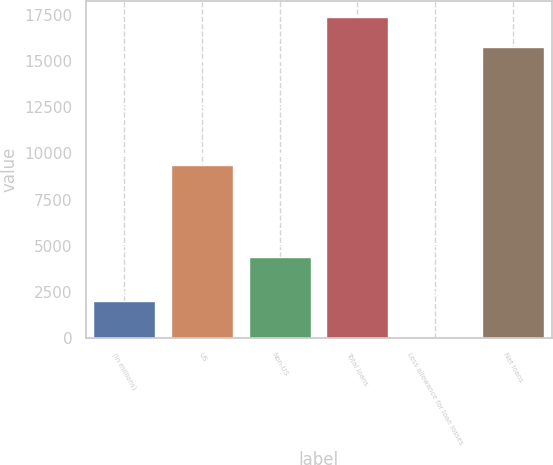<chart> <loc_0><loc_0><loc_500><loc_500><bar_chart><fcel>(In millions)<fcel>US<fcel>Non-US<fcel>Total loans<fcel>Less allowance for loan losses<fcel>Net loans<nl><fcel>2007<fcel>9402<fcel>4420<fcel>17362.4<fcel>18<fcel>15784<nl></chart> 